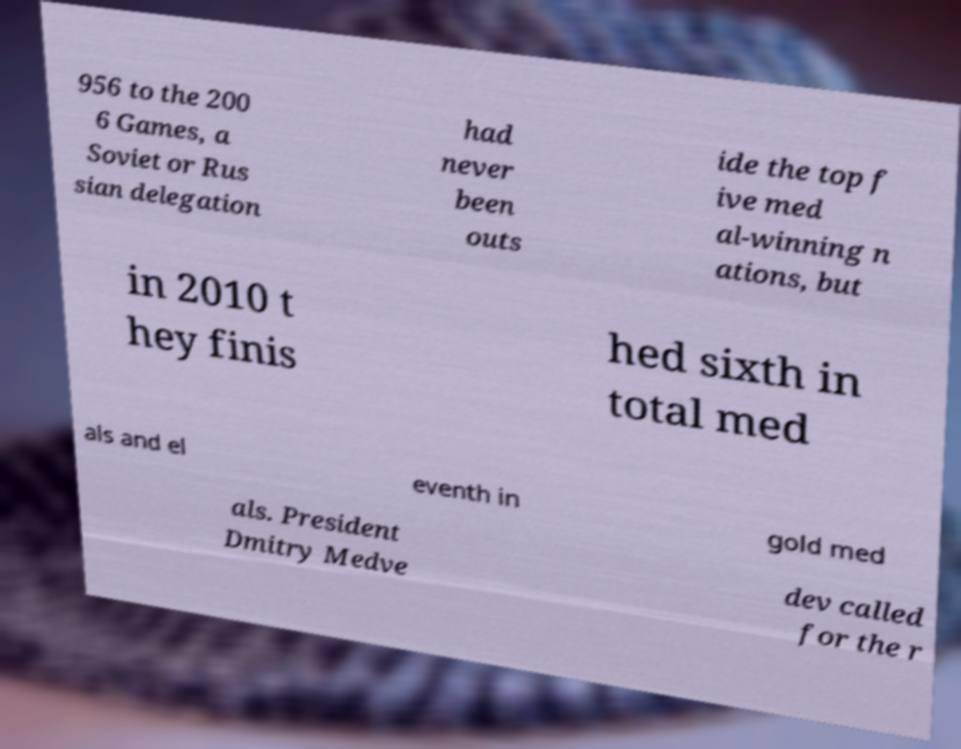Please read and relay the text visible in this image. What does it say? 956 to the 200 6 Games, a Soviet or Rus sian delegation had never been outs ide the top f ive med al-winning n ations, but in 2010 t hey finis hed sixth in total med als and el eventh in gold med als. President Dmitry Medve dev called for the r 